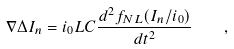Convert formula to latex. <formula><loc_0><loc_0><loc_500><loc_500>\nabla \Delta I _ { n } = i _ { 0 } L C \frac { d ^ { 2 } f _ { N L } ( I _ { n } / i _ { 0 } ) } { d t ^ { 2 } } \quad ,</formula> 